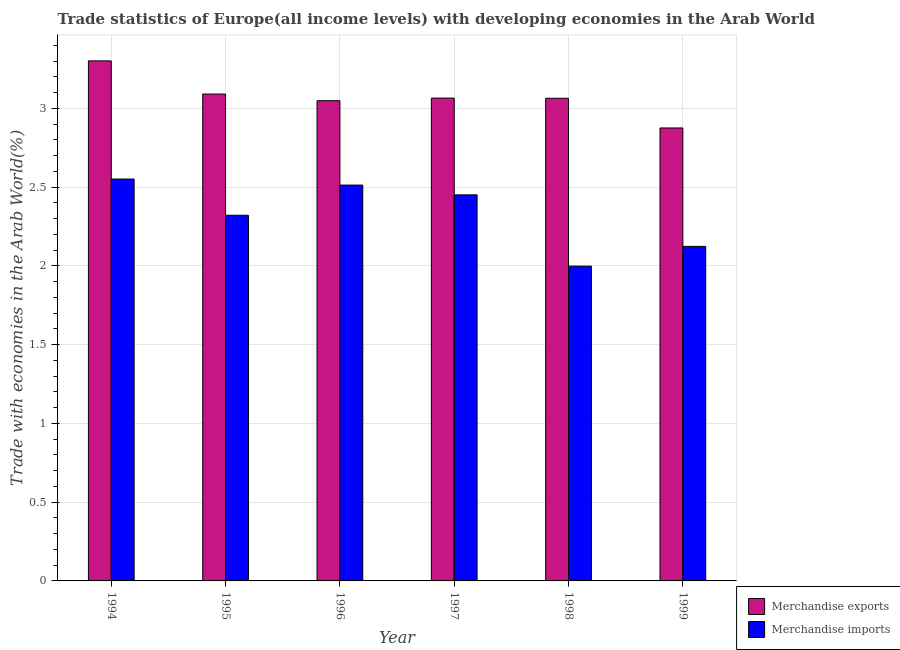How many different coloured bars are there?
Give a very brief answer. 2. Are the number of bars per tick equal to the number of legend labels?
Provide a succinct answer. Yes. Are the number of bars on each tick of the X-axis equal?
Your answer should be very brief. Yes. How many bars are there on the 3rd tick from the right?
Your answer should be very brief. 2. What is the label of the 6th group of bars from the left?
Your answer should be very brief. 1999. In how many cases, is the number of bars for a given year not equal to the number of legend labels?
Provide a succinct answer. 0. What is the merchandise imports in 1999?
Make the answer very short. 2.12. Across all years, what is the maximum merchandise exports?
Your response must be concise. 3.3. Across all years, what is the minimum merchandise exports?
Give a very brief answer. 2.88. In which year was the merchandise imports maximum?
Provide a short and direct response. 1994. In which year was the merchandise imports minimum?
Your response must be concise. 1998. What is the total merchandise imports in the graph?
Give a very brief answer. 13.96. What is the difference between the merchandise imports in 1995 and that in 1998?
Make the answer very short. 0.32. What is the difference between the merchandise imports in 1994 and the merchandise exports in 1999?
Your answer should be very brief. 0.43. What is the average merchandise imports per year?
Offer a terse response. 2.33. What is the ratio of the merchandise imports in 1998 to that in 1999?
Your response must be concise. 0.94. Is the merchandise exports in 1996 less than that in 1999?
Offer a terse response. No. Is the difference between the merchandise exports in 1997 and 1998 greater than the difference between the merchandise imports in 1997 and 1998?
Offer a very short reply. No. What is the difference between the highest and the second highest merchandise exports?
Provide a succinct answer. 0.21. What is the difference between the highest and the lowest merchandise imports?
Keep it short and to the point. 0.55. What does the 1st bar from the right in 1994 represents?
Your answer should be very brief. Merchandise imports. How many bars are there?
Offer a terse response. 12. Are all the bars in the graph horizontal?
Your answer should be very brief. No. What is the difference between two consecutive major ticks on the Y-axis?
Your answer should be compact. 0.5. Are the values on the major ticks of Y-axis written in scientific E-notation?
Keep it short and to the point. No. Does the graph contain grids?
Ensure brevity in your answer.  Yes. Where does the legend appear in the graph?
Provide a succinct answer. Bottom right. How are the legend labels stacked?
Your answer should be compact. Vertical. What is the title of the graph?
Offer a terse response. Trade statistics of Europe(all income levels) with developing economies in the Arab World. What is the label or title of the Y-axis?
Ensure brevity in your answer.  Trade with economies in the Arab World(%). What is the Trade with economies in the Arab World(%) of Merchandise exports in 1994?
Keep it short and to the point. 3.3. What is the Trade with economies in the Arab World(%) in Merchandise imports in 1994?
Your answer should be compact. 2.55. What is the Trade with economies in the Arab World(%) of Merchandise exports in 1995?
Keep it short and to the point. 3.09. What is the Trade with economies in the Arab World(%) in Merchandise imports in 1995?
Your answer should be very brief. 2.32. What is the Trade with economies in the Arab World(%) in Merchandise exports in 1996?
Give a very brief answer. 3.05. What is the Trade with economies in the Arab World(%) of Merchandise imports in 1996?
Give a very brief answer. 2.51. What is the Trade with economies in the Arab World(%) in Merchandise exports in 1997?
Provide a short and direct response. 3.07. What is the Trade with economies in the Arab World(%) of Merchandise imports in 1997?
Provide a short and direct response. 2.45. What is the Trade with economies in the Arab World(%) of Merchandise exports in 1998?
Ensure brevity in your answer.  3.06. What is the Trade with economies in the Arab World(%) in Merchandise imports in 1998?
Offer a terse response. 2. What is the Trade with economies in the Arab World(%) of Merchandise exports in 1999?
Provide a succinct answer. 2.88. What is the Trade with economies in the Arab World(%) in Merchandise imports in 1999?
Offer a terse response. 2.12. Across all years, what is the maximum Trade with economies in the Arab World(%) in Merchandise exports?
Your response must be concise. 3.3. Across all years, what is the maximum Trade with economies in the Arab World(%) of Merchandise imports?
Provide a succinct answer. 2.55. Across all years, what is the minimum Trade with economies in the Arab World(%) in Merchandise exports?
Your answer should be compact. 2.88. Across all years, what is the minimum Trade with economies in the Arab World(%) in Merchandise imports?
Your response must be concise. 2. What is the total Trade with economies in the Arab World(%) of Merchandise exports in the graph?
Provide a short and direct response. 18.45. What is the total Trade with economies in the Arab World(%) in Merchandise imports in the graph?
Ensure brevity in your answer.  13.96. What is the difference between the Trade with economies in the Arab World(%) in Merchandise exports in 1994 and that in 1995?
Provide a short and direct response. 0.21. What is the difference between the Trade with economies in the Arab World(%) in Merchandise imports in 1994 and that in 1995?
Provide a succinct answer. 0.23. What is the difference between the Trade with economies in the Arab World(%) of Merchandise exports in 1994 and that in 1996?
Offer a terse response. 0.25. What is the difference between the Trade with economies in the Arab World(%) in Merchandise imports in 1994 and that in 1996?
Your answer should be very brief. 0.04. What is the difference between the Trade with economies in the Arab World(%) in Merchandise exports in 1994 and that in 1997?
Make the answer very short. 0.24. What is the difference between the Trade with economies in the Arab World(%) in Merchandise imports in 1994 and that in 1997?
Your answer should be compact. 0.1. What is the difference between the Trade with economies in the Arab World(%) of Merchandise exports in 1994 and that in 1998?
Your answer should be very brief. 0.24. What is the difference between the Trade with economies in the Arab World(%) in Merchandise imports in 1994 and that in 1998?
Keep it short and to the point. 0.55. What is the difference between the Trade with economies in the Arab World(%) of Merchandise exports in 1994 and that in 1999?
Your answer should be compact. 0.43. What is the difference between the Trade with economies in the Arab World(%) in Merchandise imports in 1994 and that in 1999?
Your answer should be very brief. 0.43. What is the difference between the Trade with economies in the Arab World(%) in Merchandise exports in 1995 and that in 1996?
Give a very brief answer. 0.04. What is the difference between the Trade with economies in the Arab World(%) of Merchandise imports in 1995 and that in 1996?
Keep it short and to the point. -0.19. What is the difference between the Trade with economies in the Arab World(%) of Merchandise exports in 1995 and that in 1997?
Provide a short and direct response. 0.03. What is the difference between the Trade with economies in the Arab World(%) of Merchandise imports in 1995 and that in 1997?
Provide a succinct answer. -0.13. What is the difference between the Trade with economies in the Arab World(%) in Merchandise exports in 1995 and that in 1998?
Provide a short and direct response. 0.03. What is the difference between the Trade with economies in the Arab World(%) of Merchandise imports in 1995 and that in 1998?
Ensure brevity in your answer.  0.32. What is the difference between the Trade with economies in the Arab World(%) in Merchandise exports in 1995 and that in 1999?
Make the answer very short. 0.22. What is the difference between the Trade with economies in the Arab World(%) in Merchandise imports in 1995 and that in 1999?
Your response must be concise. 0.2. What is the difference between the Trade with economies in the Arab World(%) in Merchandise exports in 1996 and that in 1997?
Keep it short and to the point. -0.02. What is the difference between the Trade with economies in the Arab World(%) in Merchandise imports in 1996 and that in 1997?
Ensure brevity in your answer.  0.06. What is the difference between the Trade with economies in the Arab World(%) of Merchandise exports in 1996 and that in 1998?
Ensure brevity in your answer.  -0.02. What is the difference between the Trade with economies in the Arab World(%) in Merchandise imports in 1996 and that in 1998?
Provide a short and direct response. 0.51. What is the difference between the Trade with economies in the Arab World(%) of Merchandise exports in 1996 and that in 1999?
Ensure brevity in your answer.  0.17. What is the difference between the Trade with economies in the Arab World(%) in Merchandise imports in 1996 and that in 1999?
Offer a very short reply. 0.39. What is the difference between the Trade with economies in the Arab World(%) of Merchandise exports in 1997 and that in 1998?
Provide a succinct answer. 0. What is the difference between the Trade with economies in the Arab World(%) in Merchandise imports in 1997 and that in 1998?
Provide a succinct answer. 0.45. What is the difference between the Trade with economies in the Arab World(%) of Merchandise exports in 1997 and that in 1999?
Your answer should be very brief. 0.19. What is the difference between the Trade with economies in the Arab World(%) in Merchandise imports in 1997 and that in 1999?
Provide a succinct answer. 0.33. What is the difference between the Trade with economies in the Arab World(%) of Merchandise exports in 1998 and that in 1999?
Offer a very short reply. 0.19. What is the difference between the Trade with economies in the Arab World(%) in Merchandise imports in 1998 and that in 1999?
Offer a very short reply. -0.13. What is the difference between the Trade with economies in the Arab World(%) of Merchandise exports in 1994 and the Trade with economies in the Arab World(%) of Merchandise imports in 1995?
Your answer should be compact. 0.98. What is the difference between the Trade with economies in the Arab World(%) in Merchandise exports in 1994 and the Trade with economies in the Arab World(%) in Merchandise imports in 1996?
Your answer should be very brief. 0.79. What is the difference between the Trade with economies in the Arab World(%) in Merchandise exports in 1994 and the Trade with economies in the Arab World(%) in Merchandise imports in 1997?
Your answer should be compact. 0.85. What is the difference between the Trade with economies in the Arab World(%) in Merchandise exports in 1994 and the Trade with economies in the Arab World(%) in Merchandise imports in 1998?
Ensure brevity in your answer.  1.3. What is the difference between the Trade with economies in the Arab World(%) in Merchandise exports in 1994 and the Trade with economies in the Arab World(%) in Merchandise imports in 1999?
Keep it short and to the point. 1.18. What is the difference between the Trade with economies in the Arab World(%) in Merchandise exports in 1995 and the Trade with economies in the Arab World(%) in Merchandise imports in 1996?
Offer a terse response. 0.58. What is the difference between the Trade with economies in the Arab World(%) in Merchandise exports in 1995 and the Trade with economies in the Arab World(%) in Merchandise imports in 1997?
Offer a very short reply. 0.64. What is the difference between the Trade with economies in the Arab World(%) of Merchandise exports in 1995 and the Trade with economies in the Arab World(%) of Merchandise imports in 1998?
Your response must be concise. 1.09. What is the difference between the Trade with economies in the Arab World(%) in Merchandise exports in 1995 and the Trade with economies in the Arab World(%) in Merchandise imports in 1999?
Your answer should be very brief. 0.97. What is the difference between the Trade with economies in the Arab World(%) in Merchandise exports in 1996 and the Trade with economies in the Arab World(%) in Merchandise imports in 1997?
Your response must be concise. 0.6. What is the difference between the Trade with economies in the Arab World(%) of Merchandise exports in 1996 and the Trade with economies in the Arab World(%) of Merchandise imports in 1998?
Ensure brevity in your answer.  1.05. What is the difference between the Trade with economies in the Arab World(%) of Merchandise exports in 1996 and the Trade with economies in the Arab World(%) of Merchandise imports in 1999?
Keep it short and to the point. 0.92. What is the difference between the Trade with economies in the Arab World(%) in Merchandise exports in 1997 and the Trade with economies in the Arab World(%) in Merchandise imports in 1998?
Give a very brief answer. 1.07. What is the difference between the Trade with economies in the Arab World(%) in Merchandise exports in 1997 and the Trade with economies in the Arab World(%) in Merchandise imports in 1999?
Ensure brevity in your answer.  0.94. What is the difference between the Trade with economies in the Arab World(%) of Merchandise exports in 1998 and the Trade with economies in the Arab World(%) of Merchandise imports in 1999?
Make the answer very short. 0.94. What is the average Trade with economies in the Arab World(%) in Merchandise exports per year?
Give a very brief answer. 3.07. What is the average Trade with economies in the Arab World(%) in Merchandise imports per year?
Your response must be concise. 2.33. In the year 1994, what is the difference between the Trade with economies in the Arab World(%) in Merchandise exports and Trade with economies in the Arab World(%) in Merchandise imports?
Your answer should be very brief. 0.75. In the year 1995, what is the difference between the Trade with economies in the Arab World(%) of Merchandise exports and Trade with economies in the Arab World(%) of Merchandise imports?
Offer a very short reply. 0.77. In the year 1996, what is the difference between the Trade with economies in the Arab World(%) of Merchandise exports and Trade with economies in the Arab World(%) of Merchandise imports?
Your answer should be very brief. 0.54. In the year 1997, what is the difference between the Trade with economies in the Arab World(%) of Merchandise exports and Trade with economies in the Arab World(%) of Merchandise imports?
Offer a terse response. 0.61. In the year 1998, what is the difference between the Trade with economies in the Arab World(%) of Merchandise exports and Trade with economies in the Arab World(%) of Merchandise imports?
Your answer should be compact. 1.07. In the year 1999, what is the difference between the Trade with economies in the Arab World(%) of Merchandise exports and Trade with economies in the Arab World(%) of Merchandise imports?
Offer a very short reply. 0.75. What is the ratio of the Trade with economies in the Arab World(%) in Merchandise exports in 1994 to that in 1995?
Your answer should be compact. 1.07. What is the ratio of the Trade with economies in the Arab World(%) in Merchandise imports in 1994 to that in 1995?
Your answer should be compact. 1.1. What is the ratio of the Trade with economies in the Arab World(%) in Merchandise exports in 1994 to that in 1996?
Make the answer very short. 1.08. What is the ratio of the Trade with economies in the Arab World(%) in Merchandise imports in 1994 to that in 1996?
Make the answer very short. 1.02. What is the ratio of the Trade with economies in the Arab World(%) in Merchandise exports in 1994 to that in 1997?
Offer a terse response. 1.08. What is the ratio of the Trade with economies in the Arab World(%) of Merchandise imports in 1994 to that in 1997?
Your answer should be compact. 1.04. What is the ratio of the Trade with economies in the Arab World(%) in Merchandise exports in 1994 to that in 1998?
Make the answer very short. 1.08. What is the ratio of the Trade with economies in the Arab World(%) of Merchandise imports in 1994 to that in 1998?
Your response must be concise. 1.28. What is the ratio of the Trade with economies in the Arab World(%) in Merchandise exports in 1994 to that in 1999?
Keep it short and to the point. 1.15. What is the ratio of the Trade with economies in the Arab World(%) in Merchandise imports in 1994 to that in 1999?
Give a very brief answer. 1.2. What is the ratio of the Trade with economies in the Arab World(%) of Merchandise exports in 1995 to that in 1996?
Your answer should be compact. 1.01. What is the ratio of the Trade with economies in the Arab World(%) of Merchandise imports in 1995 to that in 1996?
Your answer should be compact. 0.92. What is the ratio of the Trade with economies in the Arab World(%) in Merchandise exports in 1995 to that in 1997?
Make the answer very short. 1.01. What is the ratio of the Trade with economies in the Arab World(%) of Merchandise imports in 1995 to that in 1997?
Make the answer very short. 0.95. What is the ratio of the Trade with economies in the Arab World(%) of Merchandise exports in 1995 to that in 1998?
Provide a succinct answer. 1.01. What is the ratio of the Trade with economies in the Arab World(%) of Merchandise imports in 1995 to that in 1998?
Offer a very short reply. 1.16. What is the ratio of the Trade with economies in the Arab World(%) of Merchandise exports in 1995 to that in 1999?
Offer a very short reply. 1.07. What is the ratio of the Trade with economies in the Arab World(%) of Merchandise imports in 1995 to that in 1999?
Make the answer very short. 1.09. What is the ratio of the Trade with economies in the Arab World(%) of Merchandise imports in 1996 to that in 1997?
Provide a succinct answer. 1.03. What is the ratio of the Trade with economies in the Arab World(%) in Merchandise imports in 1996 to that in 1998?
Your response must be concise. 1.26. What is the ratio of the Trade with economies in the Arab World(%) of Merchandise exports in 1996 to that in 1999?
Ensure brevity in your answer.  1.06. What is the ratio of the Trade with economies in the Arab World(%) of Merchandise imports in 1996 to that in 1999?
Provide a short and direct response. 1.18. What is the ratio of the Trade with economies in the Arab World(%) in Merchandise exports in 1997 to that in 1998?
Offer a terse response. 1. What is the ratio of the Trade with economies in the Arab World(%) of Merchandise imports in 1997 to that in 1998?
Provide a short and direct response. 1.23. What is the ratio of the Trade with economies in the Arab World(%) of Merchandise exports in 1997 to that in 1999?
Your answer should be very brief. 1.07. What is the ratio of the Trade with economies in the Arab World(%) of Merchandise imports in 1997 to that in 1999?
Provide a succinct answer. 1.15. What is the ratio of the Trade with economies in the Arab World(%) of Merchandise exports in 1998 to that in 1999?
Give a very brief answer. 1.07. What is the ratio of the Trade with economies in the Arab World(%) in Merchandise imports in 1998 to that in 1999?
Make the answer very short. 0.94. What is the difference between the highest and the second highest Trade with economies in the Arab World(%) of Merchandise exports?
Keep it short and to the point. 0.21. What is the difference between the highest and the second highest Trade with economies in the Arab World(%) of Merchandise imports?
Your answer should be very brief. 0.04. What is the difference between the highest and the lowest Trade with economies in the Arab World(%) in Merchandise exports?
Give a very brief answer. 0.43. What is the difference between the highest and the lowest Trade with economies in the Arab World(%) in Merchandise imports?
Provide a succinct answer. 0.55. 